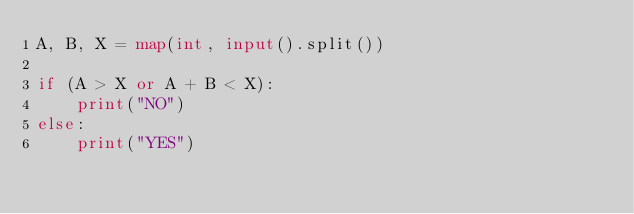<code> <loc_0><loc_0><loc_500><loc_500><_Python_>A, B, X = map(int, input().split())

if (A > X or A + B < X):
    print("NO")
else:
    print("YES")
</code> 